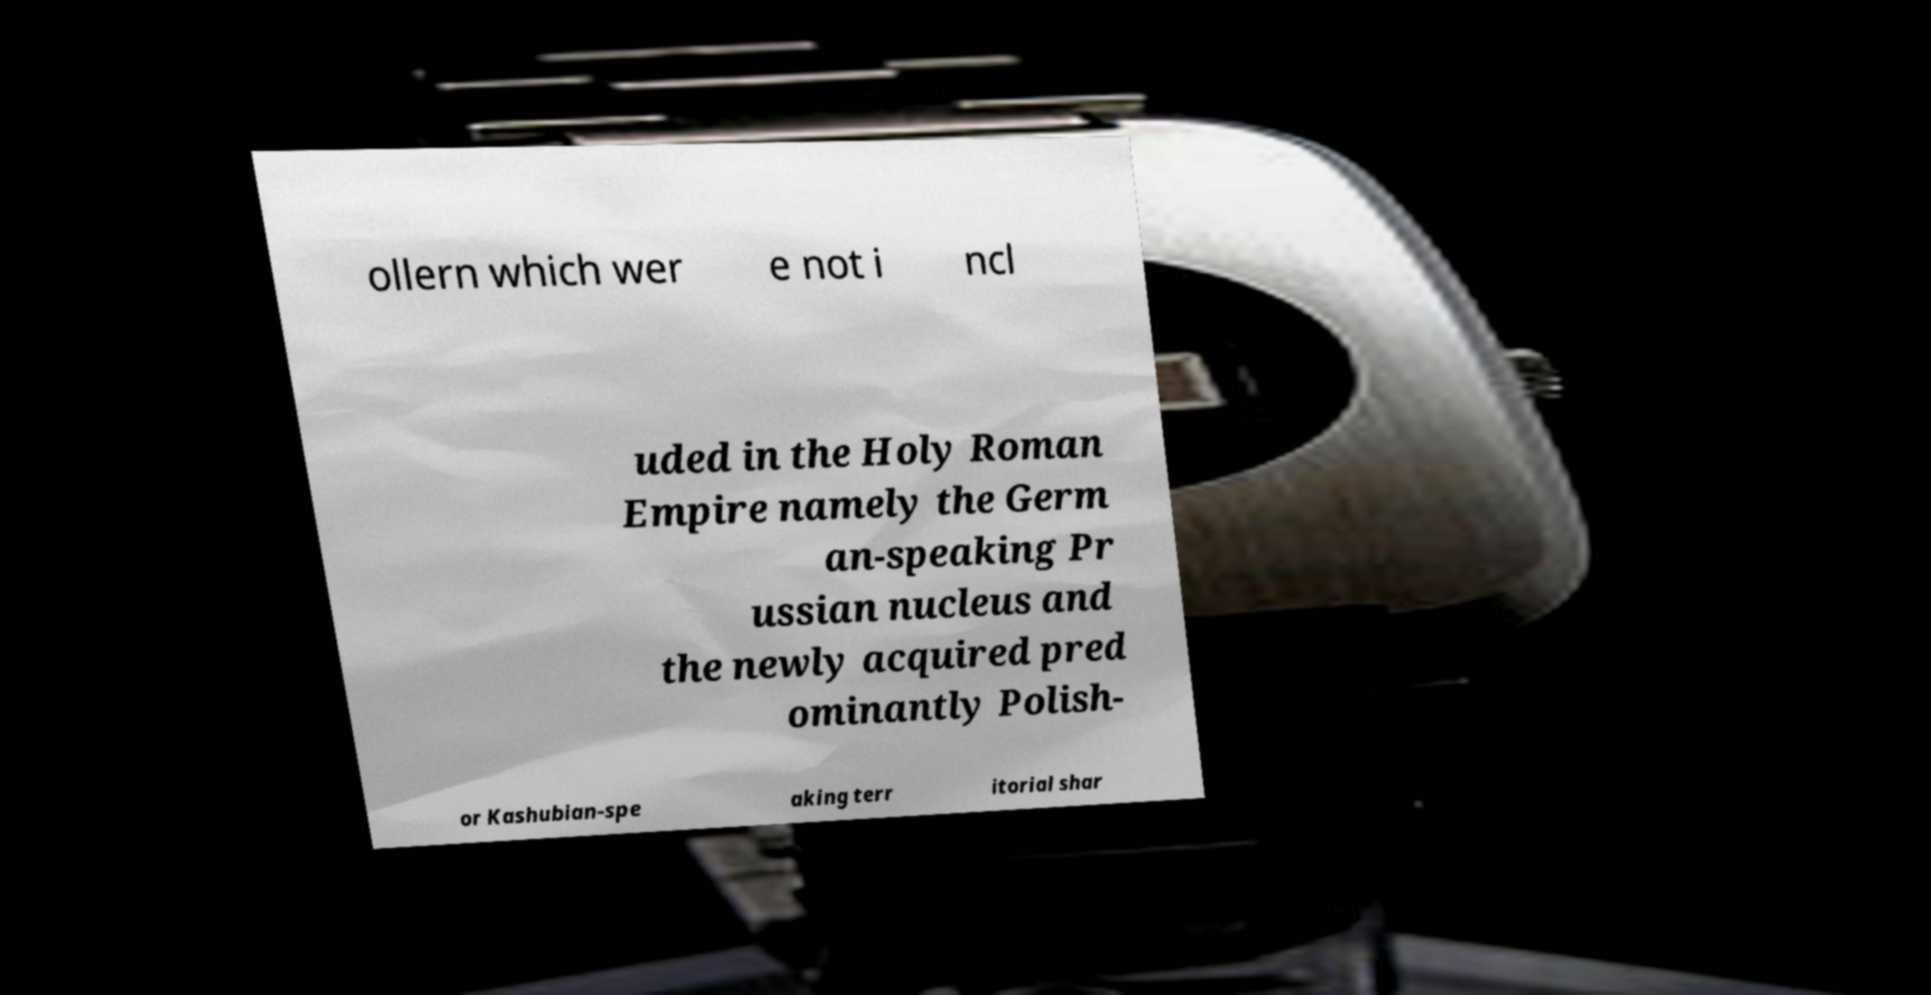Could you assist in decoding the text presented in this image and type it out clearly? ollern which wer e not i ncl uded in the Holy Roman Empire namely the Germ an-speaking Pr ussian nucleus and the newly acquired pred ominantly Polish- or Kashubian-spe aking terr itorial shar 